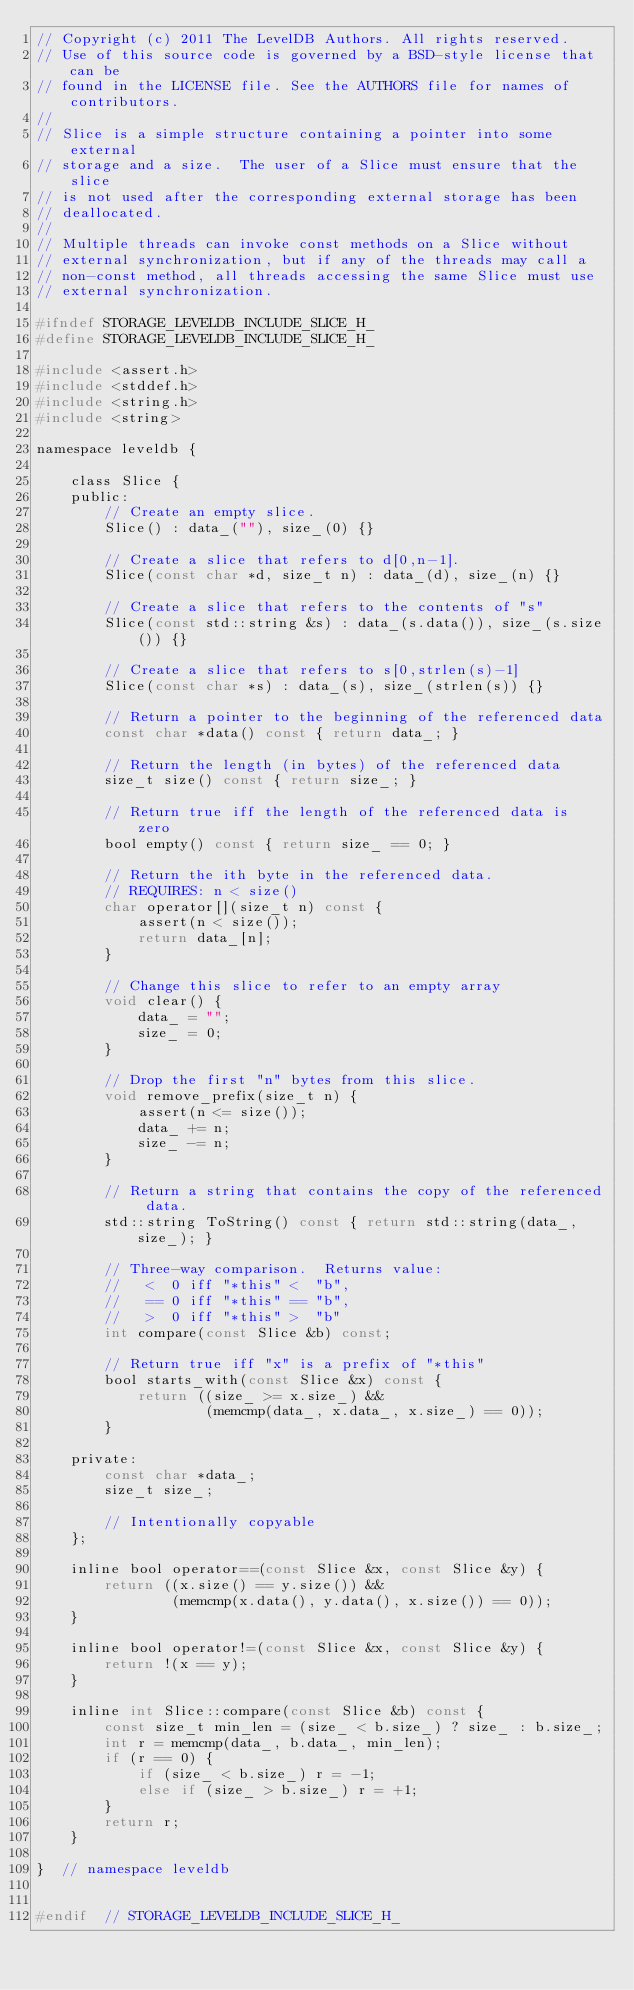Convert code to text. <code><loc_0><loc_0><loc_500><loc_500><_C_>// Copyright (c) 2011 The LevelDB Authors. All rights reserved.
// Use of this source code is governed by a BSD-style license that can be
// found in the LICENSE file. See the AUTHORS file for names of contributors.
//
// Slice is a simple structure containing a pointer into some external
// storage and a size.  The user of a Slice must ensure that the slice
// is not used after the corresponding external storage has been
// deallocated.
//
// Multiple threads can invoke const methods on a Slice without
// external synchronization, but if any of the threads may call a
// non-const method, all threads accessing the same Slice must use
// external synchronization.

#ifndef STORAGE_LEVELDB_INCLUDE_SLICE_H_
#define STORAGE_LEVELDB_INCLUDE_SLICE_H_

#include <assert.h>
#include <stddef.h>
#include <string.h>
#include <string>

namespace leveldb {

    class Slice {
    public:
        // Create an empty slice.
        Slice() : data_(""), size_(0) {}

        // Create a slice that refers to d[0,n-1].
        Slice(const char *d, size_t n) : data_(d), size_(n) {}

        // Create a slice that refers to the contents of "s"
        Slice(const std::string &s) : data_(s.data()), size_(s.size()) {}

        // Create a slice that refers to s[0,strlen(s)-1]
        Slice(const char *s) : data_(s), size_(strlen(s)) {}

        // Return a pointer to the beginning of the referenced data
        const char *data() const { return data_; }

        // Return the length (in bytes) of the referenced data
        size_t size() const { return size_; }

        // Return true iff the length of the referenced data is zero
        bool empty() const { return size_ == 0; }

        // Return the ith byte in the referenced data.
        // REQUIRES: n < size()
        char operator[](size_t n) const {
            assert(n < size());
            return data_[n];
        }

        // Change this slice to refer to an empty array
        void clear() {
            data_ = "";
            size_ = 0;
        }

        // Drop the first "n" bytes from this slice.
        void remove_prefix(size_t n) {
            assert(n <= size());
            data_ += n;
            size_ -= n;
        }

        // Return a string that contains the copy of the referenced data.
        std::string ToString() const { return std::string(data_, size_); }

        // Three-way comparison.  Returns value:
        //   <  0 iff "*this" <  "b",
        //   == 0 iff "*this" == "b",
        //   >  0 iff "*this" >  "b"
        int compare(const Slice &b) const;

        // Return true iff "x" is a prefix of "*this"
        bool starts_with(const Slice &x) const {
            return ((size_ >= x.size_) &&
                    (memcmp(data_, x.data_, x.size_) == 0));
        }

    private:
        const char *data_;
        size_t size_;

        // Intentionally copyable
    };

    inline bool operator==(const Slice &x, const Slice &y) {
        return ((x.size() == y.size()) &&
                (memcmp(x.data(), y.data(), x.size()) == 0));
    }

    inline bool operator!=(const Slice &x, const Slice &y) {
        return !(x == y);
    }

    inline int Slice::compare(const Slice &b) const {
        const size_t min_len = (size_ < b.size_) ? size_ : b.size_;
        int r = memcmp(data_, b.data_, min_len);
        if (r == 0) {
            if (size_ < b.size_) r = -1;
            else if (size_ > b.size_) r = +1;
        }
        return r;
    }

}  // namespace leveldb


#endif  // STORAGE_LEVELDB_INCLUDE_SLICE_H_
</code> 